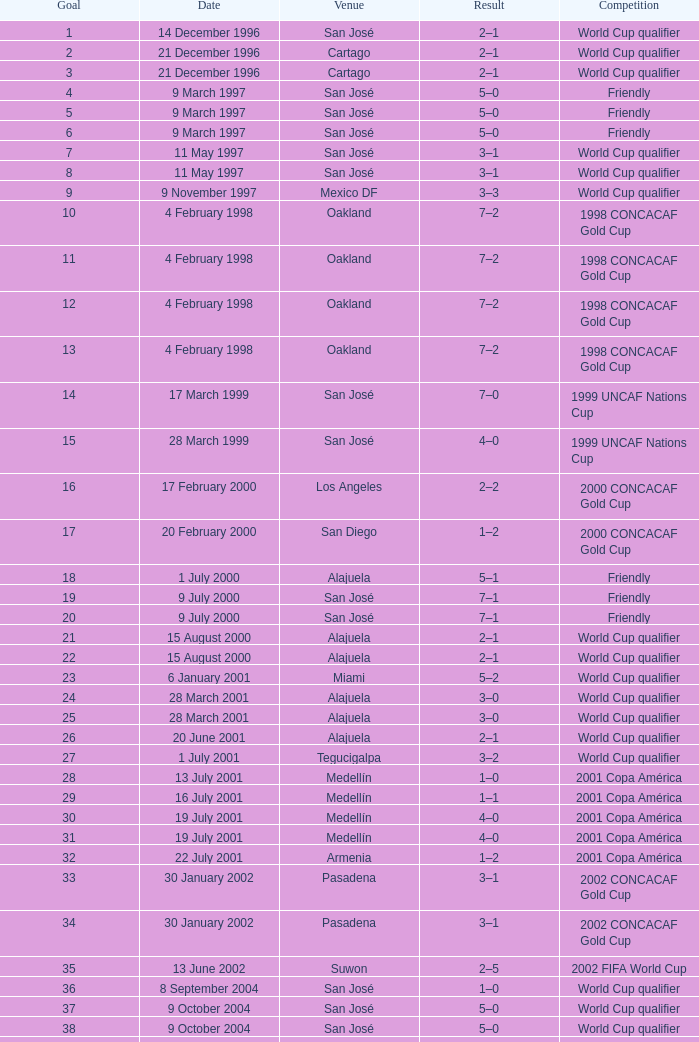What is the result in oakland? 7–2, 7–2, 7–2, 7–2. 